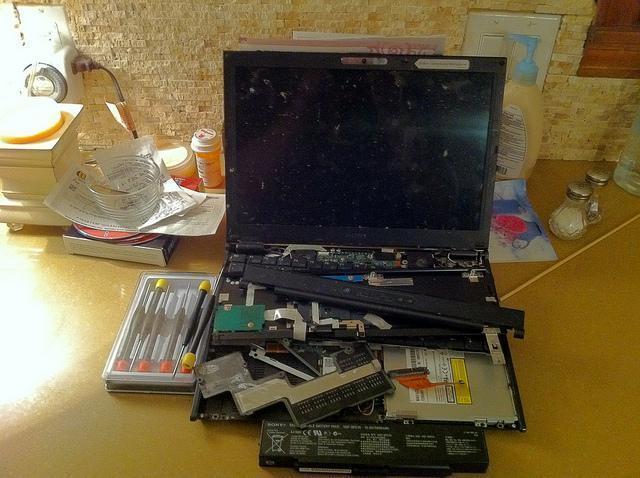How many laptops are visible?
Give a very brief answer. 1. How many oranges are in the bowl?
Give a very brief answer. 0. 